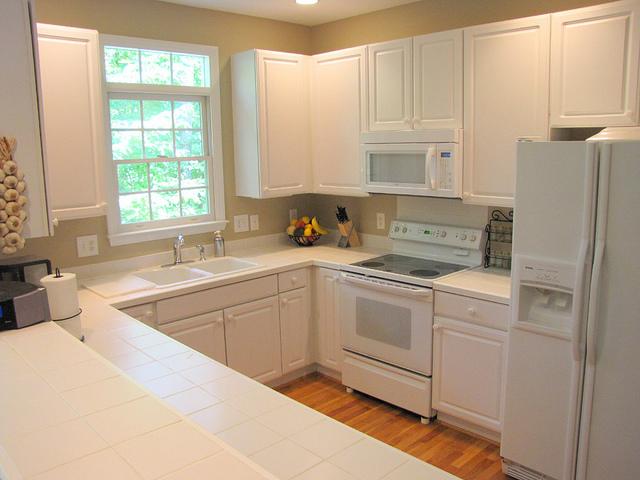What room is pictured?
Be succinct. Kitchen. Are the fruits in the basket real or wax?
Short answer required. Real. Is there a mirror in this room?
Short answer required. No. What color is the cabinet?
Answer briefly. White. What does the floor consist of?
Short answer required. Wood. What color are the appliances?
Quick response, please. White. How many windows are visible?
Keep it brief. 1. What is it for?
Keep it brief. Cooking. Is this a modern kitchen?
Quick response, please. Yes. What room is this?
Concise answer only. Kitchen. 